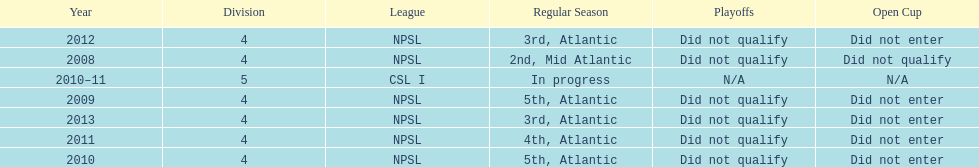Using the data, what should be the next year they will play? 2014. 